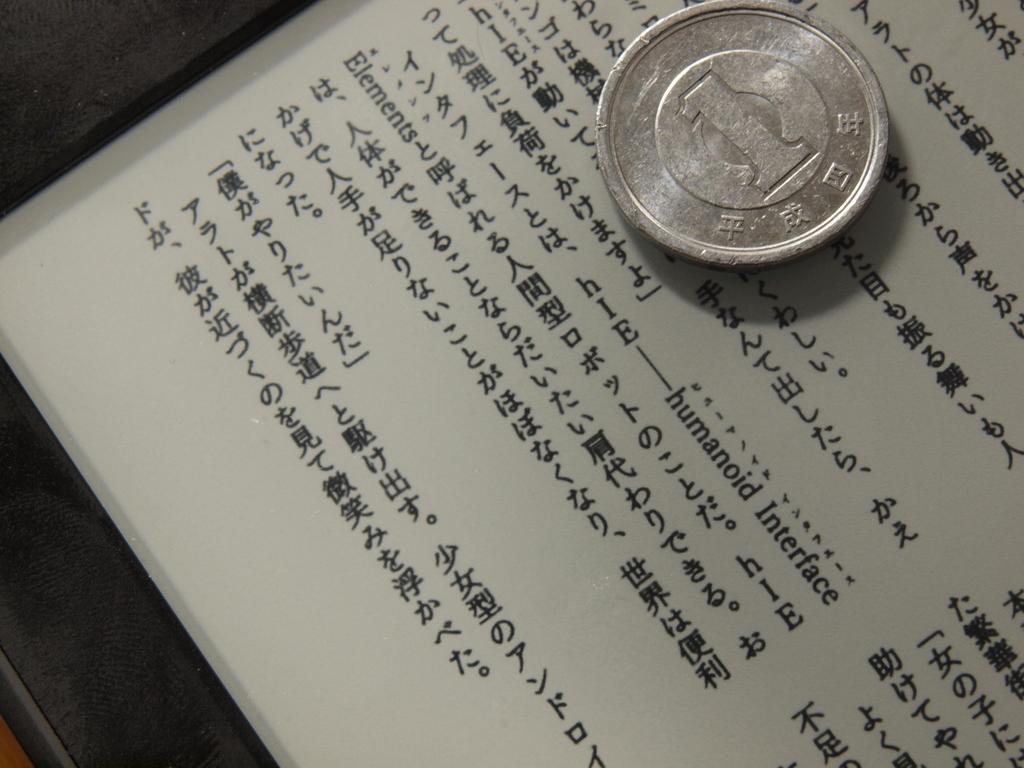What number is on this coin?
Your answer should be compact. 1. 